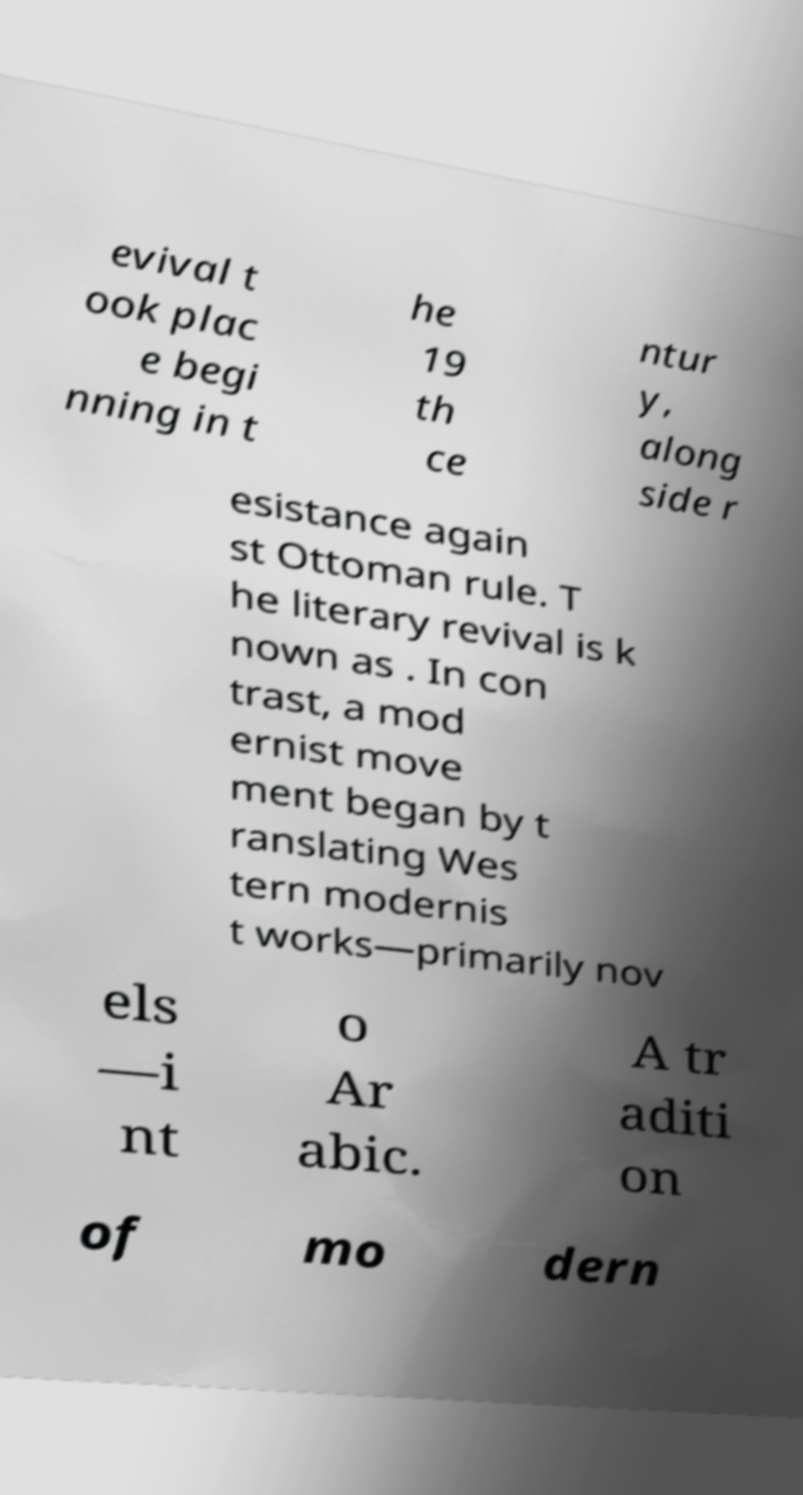Please read and relay the text visible in this image. What does it say? evival t ook plac e begi nning in t he 19 th ce ntur y, along side r esistance again st Ottoman rule. T he literary revival is k nown as . In con trast, a mod ernist move ment began by t ranslating Wes tern modernis t works—primarily nov els —i nt o Ar abic. A tr aditi on of mo dern 